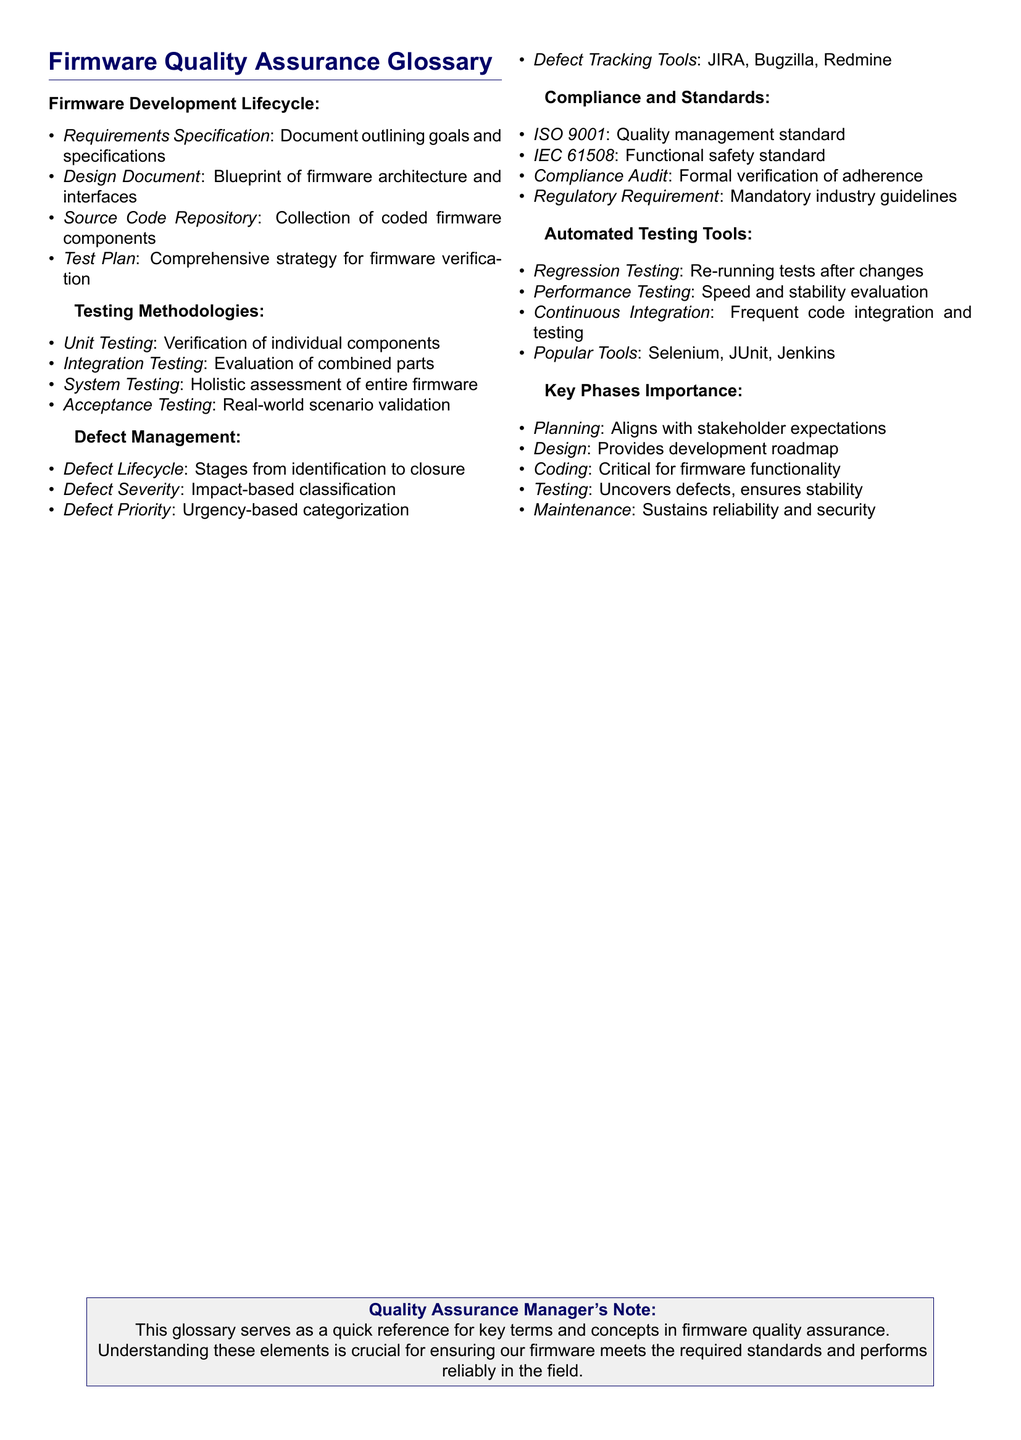What is the purpose of a Test Plan? The Test Plan is a comprehensive strategy for firmware verification, providing guidelines for testing activities.
Answer: Comprehensive strategy for firmware verification What documentation outlines goals and specifications? The Requirements Specification is the document that outlines goals and specifications for the firmware.
Answer: Requirements Specification Name a tool used for defect tracking. Defect tracking tools include various software options for documenting and managing defects, one example is JIRA.
Answer: JIRA How many phases are there in the firmware development lifecycle? The phases are critical to the development process, and they are outlined in the Key Phases Importance section, totaling five phases.
Answer: Five What does ISO 9001 represent? ISO 9001 is a quality management standard that firmware must meet among industry standards.
Answer: Quality management standard What type of testing evaluates the firmware as a whole? The System Testing methodology evaluates the combined parts of the firmware system.
Answer: System Testing What is the significance of the Planning phase? The Planning phase aligns project goals with stakeholder expectations to ensure project success.
Answer: Aligns with stakeholder expectations What does the defect severity classify? Defect Severity classifies defects based on their impact on firmware functionality and performance.
Answer: Impact-based classification What is the main benefit of automated testing tools? Automated testing tools facilitate efficient and consistent testing processes, especially for regression and performance testing.
Answer: Efficient and consistent testing processes What is the IEC 61508 standard related to? IEC 61508 is related to functional safety standards that firmware must adhere to for ensuring safety and reliability.
Answer: Functional safety standard 